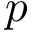<formula> <loc_0><loc_0><loc_500><loc_500>p</formula> 